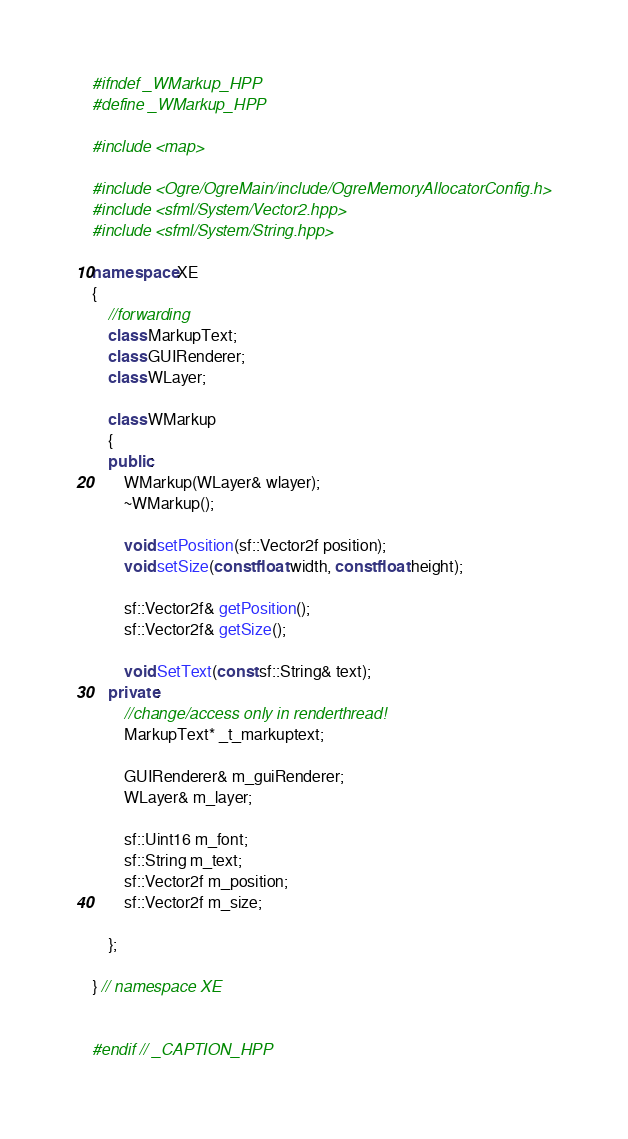<code> <loc_0><loc_0><loc_500><loc_500><_C++_>#ifndef _WMarkup_HPP
#define _WMarkup_HPP

#include <map>

#include <Ogre/OgreMain/include/OgreMemoryAllocatorConfig.h>
#include <sfml/System/Vector2.hpp>
#include <sfml/System/String.hpp>

namespace XE
{
	//forwarding
	class MarkupText;
	class GUIRenderer;
	class WLayer;

	class WMarkup
	{
	public:
		WMarkup(WLayer& wlayer);
		~WMarkup();

		void setPosition(sf::Vector2f position);
		void setSize(const float width, const float height);

		sf::Vector2f& getPosition();
		sf::Vector2f& getSize();

		void SetText(const sf::String& text);
	private:
		//change/access only in renderthread!
		MarkupText* _t_markuptext;

		GUIRenderer& m_guiRenderer;
		WLayer& m_layer;

		sf::Uint16 m_font;
		sf::String m_text;
		sf::Vector2f m_position;
		sf::Vector2f m_size;

	};

} // namespace XE


#endif // _CAPTION_HPP</code> 